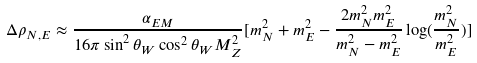<formula> <loc_0><loc_0><loc_500><loc_500>\Delta \rho _ { N , E } \approx \frac { \alpha _ { E M } } { 1 6 \pi \sin ^ { 2 } \theta _ { W } \cos ^ { 2 } \theta _ { W } M _ { Z } ^ { 2 } } [ m _ { N } ^ { 2 } + m _ { E } ^ { 2 } - \frac { 2 m _ { N } ^ { 2 } m _ { E } ^ { 2 } } { m _ { N } ^ { 2 } - m _ { E } ^ { 2 } } \log ( \frac { m _ { N } ^ { 2 } } { m _ { E } ^ { 2 } } ) ]</formula> 